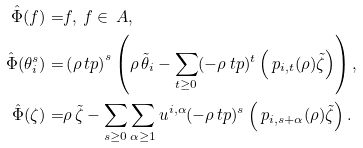Convert formula to latex. <formula><loc_0><loc_0><loc_500><loc_500>\hat { \Phi } ( f ) = & f , \ f \in \ A , \\ \hat { \Phi } ( \theta _ { i } ^ { s } ) = & \left ( \rho \ t p \right ) ^ { s } \left ( \rho \, \tilde { \theta } _ { i } - \sum _ { t \geq 0 } ( - \rho \ t p ) ^ { t } \left ( \ p _ { i , t } ( \rho ) \tilde { \zeta } \right ) \right ) , \\ \hat { \Phi } ( \zeta ) = & \rho \, \tilde { \zeta } - \sum _ { s \geq 0 } \sum _ { \alpha \geq 1 } u ^ { i , \alpha } ( - \rho \ t p ) ^ { s } \left ( \ p _ { i , s + \alpha } ( \rho ) \tilde { \zeta } \right ) .</formula> 